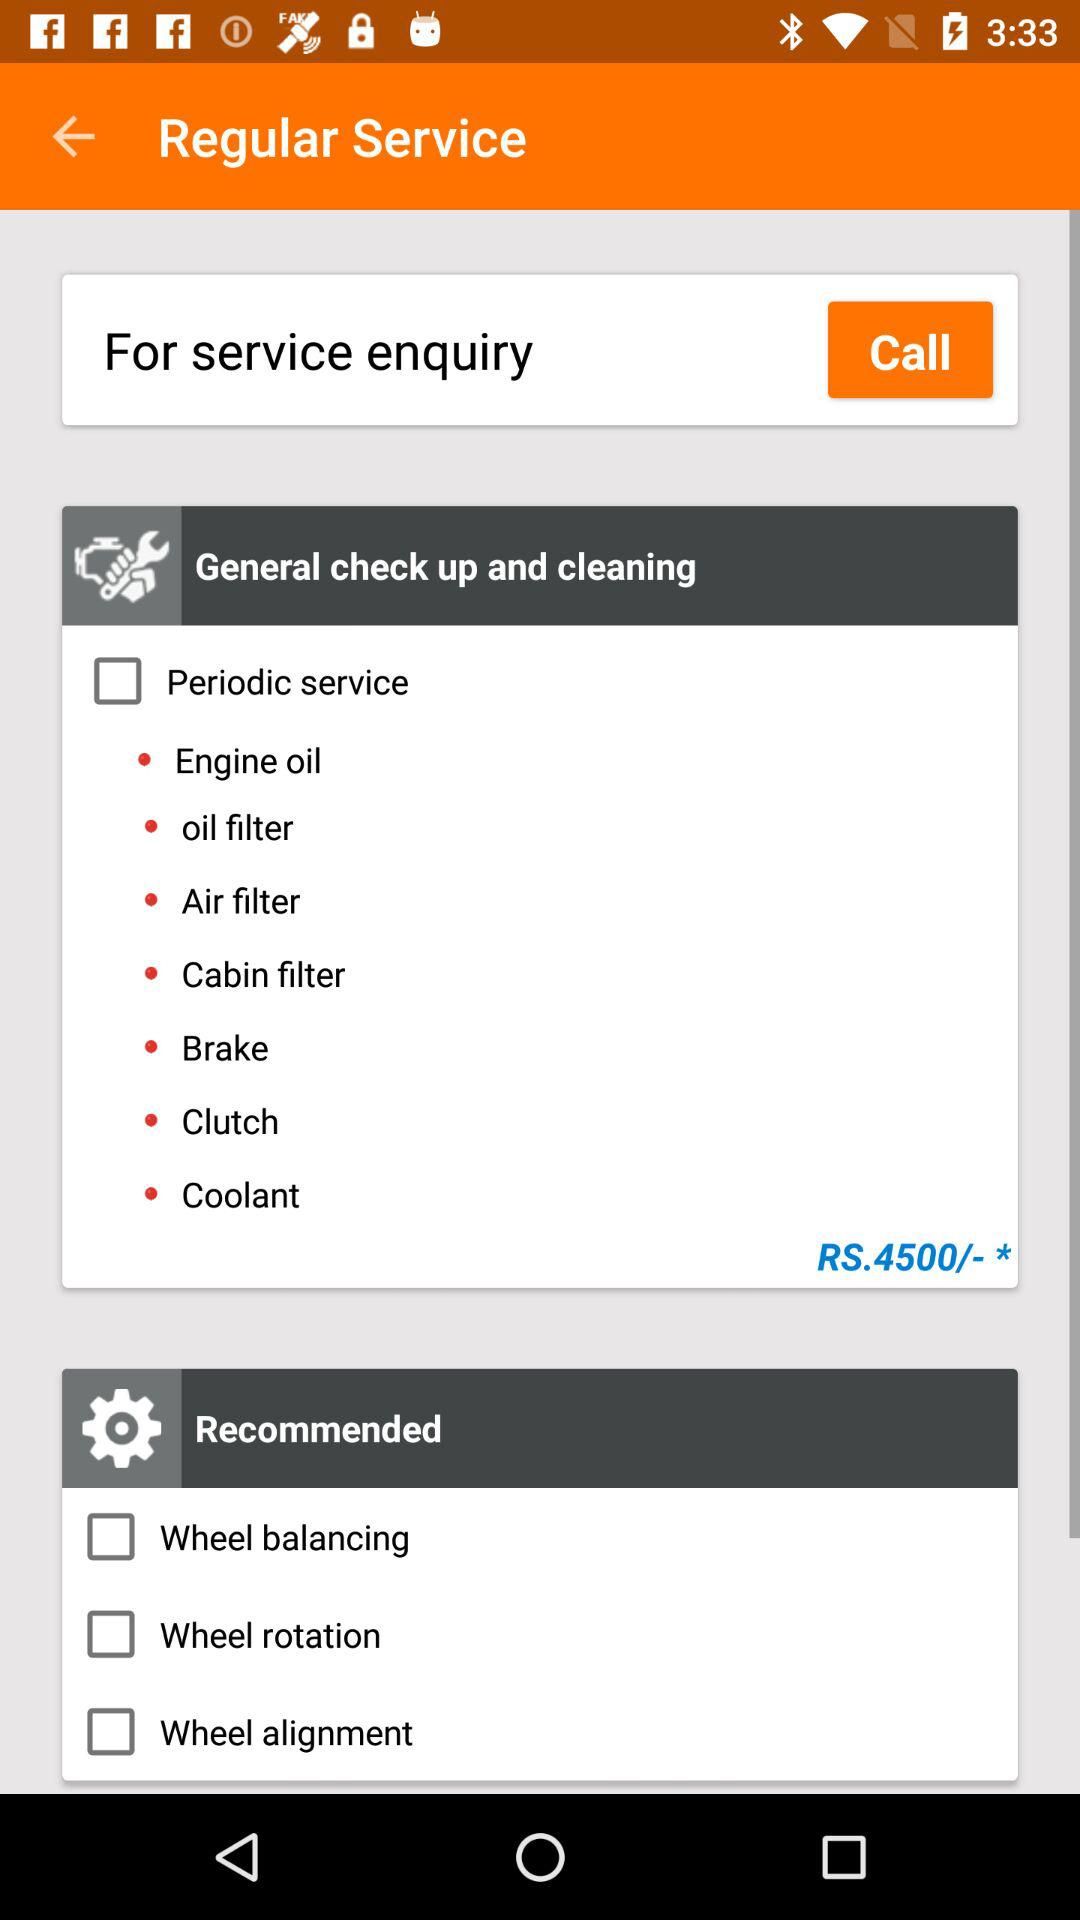What is the status of Wheel balancing? The status is off. 